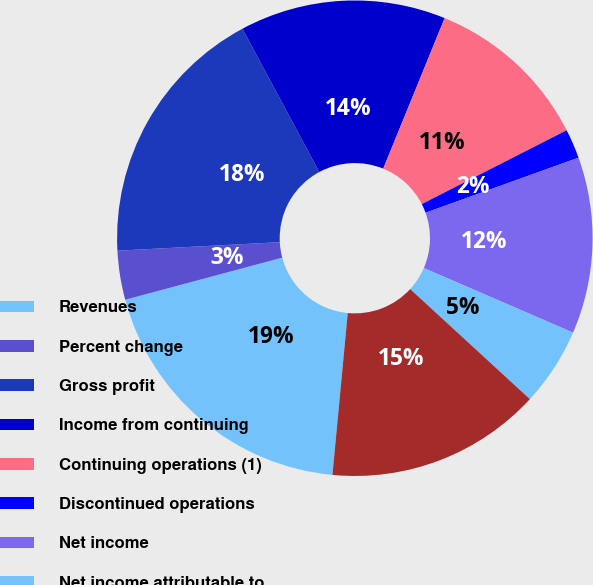Convert chart to OTSL. <chart><loc_0><loc_0><loc_500><loc_500><pie_chart><fcel>Revenues<fcel>Percent change<fcel>Gross profit<fcel>Income from continuing<fcel>Continuing operations (1)<fcel>Discontinued operations<fcel>Net income<fcel>Net income attributable to<fcel>Working capital<nl><fcel>19.33%<fcel>3.33%<fcel>18.0%<fcel>14.0%<fcel>11.33%<fcel>2.0%<fcel>12.0%<fcel>5.33%<fcel>14.67%<nl></chart> 